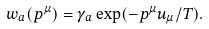<formula> <loc_0><loc_0><loc_500><loc_500>w _ { a } ( p ^ { \mu } ) = \gamma _ { a } \exp ( { - p ^ { \mu } } u _ { \mu } / T ) .</formula> 